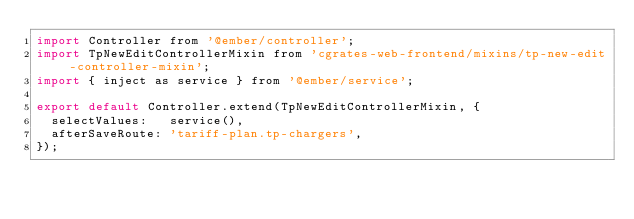<code> <loc_0><loc_0><loc_500><loc_500><_JavaScript_>import Controller from '@ember/controller';
import TpNewEditControllerMixin from 'cgrates-web-frontend/mixins/tp-new-edit-controller-mixin';
import { inject as service } from '@ember/service';

export default Controller.extend(TpNewEditControllerMixin, {
  selectValues:   service(),
  afterSaveRoute: 'tariff-plan.tp-chargers',
});
</code> 